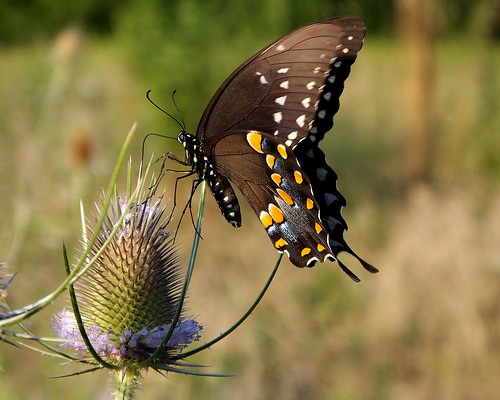<image>
Is the butterfly on the flower? Yes. Looking at the image, I can see the butterfly is positioned on top of the flower, with the flower providing support. 